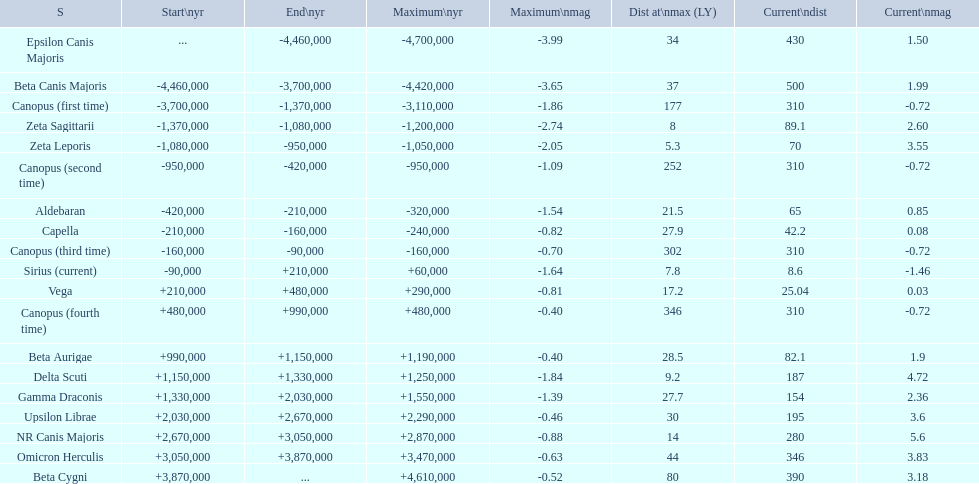What star has a a maximum magnitude of -0.63. Omicron Herculis. What star has a current distance of 390? Beta Cygni. 